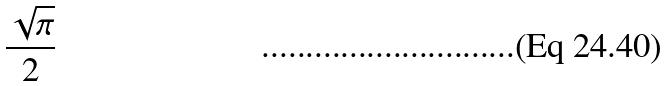<formula> <loc_0><loc_0><loc_500><loc_500>\frac { \sqrt { \pi } } { 2 }</formula> 